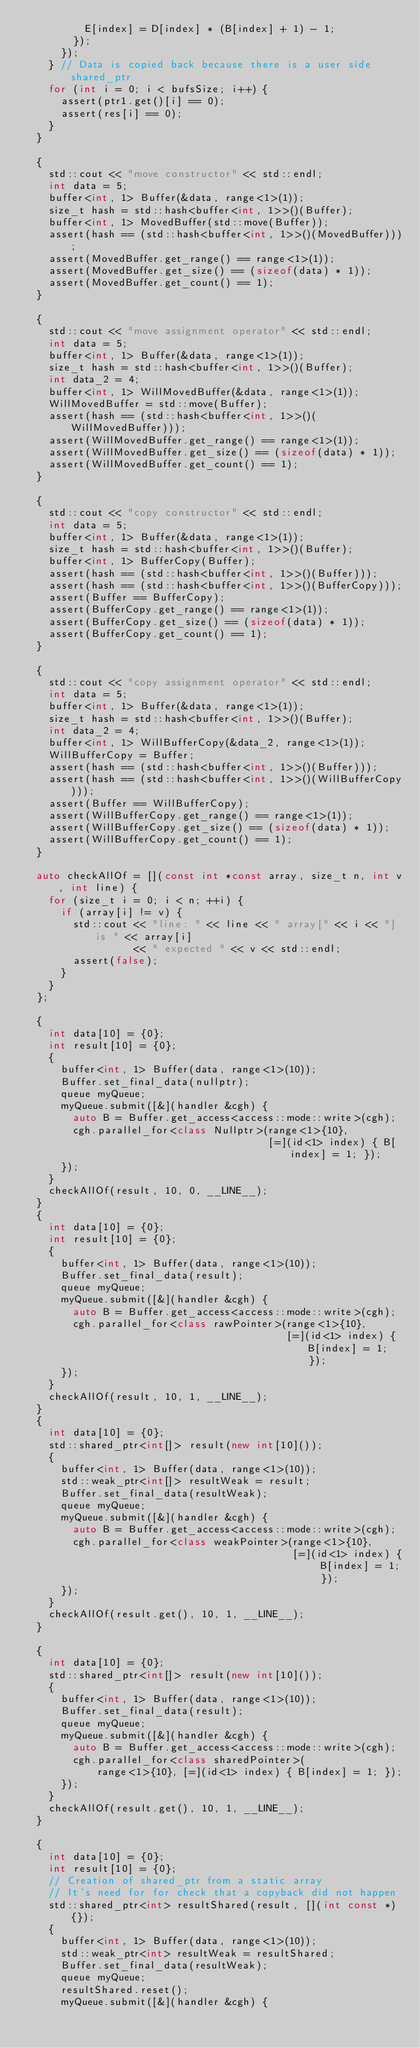<code> <loc_0><loc_0><loc_500><loc_500><_C++_>          E[index] = D[index] * (B[index] + 1) - 1;
        });
      });
    } // Data is copied back because there is a user side shared_ptr
    for (int i = 0; i < bufsSize; i++) {
      assert(ptr1.get()[i] == 0);
      assert(res[i] == 0);
    }
  }

  {
    std::cout << "move constructor" << std::endl;
    int data = 5;
    buffer<int, 1> Buffer(&data, range<1>(1));
    size_t hash = std::hash<buffer<int, 1>>()(Buffer);
    buffer<int, 1> MovedBuffer(std::move(Buffer));
    assert(hash == (std::hash<buffer<int, 1>>()(MovedBuffer)));
    assert(MovedBuffer.get_range() == range<1>(1));
    assert(MovedBuffer.get_size() == (sizeof(data) * 1));
    assert(MovedBuffer.get_count() == 1);
  }

  {
    std::cout << "move assignment operator" << std::endl;
    int data = 5;
    buffer<int, 1> Buffer(&data, range<1>(1));
    size_t hash = std::hash<buffer<int, 1>>()(Buffer);
    int data_2 = 4;
    buffer<int, 1> WillMovedBuffer(&data, range<1>(1));
    WillMovedBuffer = std::move(Buffer);
    assert(hash == (std::hash<buffer<int, 1>>()(WillMovedBuffer)));
    assert(WillMovedBuffer.get_range() == range<1>(1));
    assert(WillMovedBuffer.get_size() == (sizeof(data) * 1));
    assert(WillMovedBuffer.get_count() == 1);
  }

  {
    std::cout << "copy constructor" << std::endl;
    int data = 5;
    buffer<int, 1> Buffer(&data, range<1>(1));
    size_t hash = std::hash<buffer<int, 1>>()(Buffer);
    buffer<int, 1> BufferCopy(Buffer);
    assert(hash == (std::hash<buffer<int, 1>>()(Buffer)));
    assert(hash == (std::hash<buffer<int, 1>>()(BufferCopy)));
    assert(Buffer == BufferCopy);
    assert(BufferCopy.get_range() == range<1>(1));
    assert(BufferCopy.get_size() == (sizeof(data) * 1));
    assert(BufferCopy.get_count() == 1);
  }

  {
    std::cout << "copy assignment operator" << std::endl;
    int data = 5;
    buffer<int, 1> Buffer(&data, range<1>(1));
    size_t hash = std::hash<buffer<int, 1>>()(Buffer);
    int data_2 = 4;
    buffer<int, 1> WillBufferCopy(&data_2, range<1>(1));
    WillBufferCopy = Buffer;
    assert(hash == (std::hash<buffer<int, 1>>()(Buffer)));
    assert(hash == (std::hash<buffer<int, 1>>()(WillBufferCopy)));
    assert(Buffer == WillBufferCopy);
    assert(WillBufferCopy.get_range() == range<1>(1));
    assert(WillBufferCopy.get_size() == (sizeof(data) * 1));
    assert(WillBufferCopy.get_count() == 1);
  }

  auto checkAllOf = [](const int *const array, size_t n, int v, int line) {
    for (size_t i = 0; i < n; ++i) {
      if (array[i] != v) {
        std::cout << "line: " << line << " array[" << i << "] is " << array[i]
                  << " expected " << v << std::endl;
        assert(false);
      }
    }
  };

  {
    int data[10] = {0};
    int result[10] = {0};
    {
      buffer<int, 1> Buffer(data, range<1>(10));
      Buffer.set_final_data(nullptr);
      queue myQueue;
      myQueue.submit([&](handler &cgh) {
        auto B = Buffer.get_access<access::mode::write>(cgh);
        cgh.parallel_for<class Nullptr>(range<1>{10},
                                        [=](id<1> index) { B[index] = 1; });
      });
    }
    checkAllOf(result, 10, 0, __LINE__);
  }
  {
    int data[10] = {0};
    int result[10] = {0};
    {
      buffer<int, 1> Buffer(data, range<1>(10));
      Buffer.set_final_data(result);
      queue myQueue;
      myQueue.submit([&](handler &cgh) {
        auto B = Buffer.get_access<access::mode::write>(cgh);
        cgh.parallel_for<class rawPointer>(range<1>{10},
                                           [=](id<1> index) { B[index] = 1; });
      });
    }
    checkAllOf(result, 10, 1, __LINE__);
  }
  {
    int data[10] = {0};
    std::shared_ptr<int[]> result(new int[10]());
    {
      buffer<int, 1> Buffer(data, range<1>(10));
      std::weak_ptr<int[]> resultWeak = result;
      Buffer.set_final_data(resultWeak);
      queue myQueue;
      myQueue.submit([&](handler &cgh) {
        auto B = Buffer.get_access<access::mode::write>(cgh);
        cgh.parallel_for<class weakPointer>(range<1>{10},
                                            [=](id<1> index) { B[index] = 1; });
      });
    }
    checkAllOf(result.get(), 10, 1, __LINE__);
  }

  {
    int data[10] = {0};
    std::shared_ptr<int[]> result(new int[10]());
    {
      buffer<int, 1> Buffer(data, range<1>(10));
      Buffer.set_final_data(result);
      queue myQueue;
      myQueue.submit([&](handler &cgh) {
        auto B = Buffer.get_access<access::mode::write>(cgh);
        cgh.parallel_for<class sharedPointer>(
            range<1>{10}, [=](id<1> index) { B[index] = 1; });
      });
    }
    checkAllOf(result.get(), 10, 1, __LINE__);
  }

  {
    int data[10] = {0};
    int result[10] = {0};
    // Creation of shared_ptr from a static array
    // It's need for for check that a copyback did not happen
    std::shared_ptr<int> resultShared(result, [](int const *) {});
    {
      buffer<int, 1> Buffer(data, range<1>(10));
      std::weak_ptr<int> resultWeak = resultShared;
      Buffer.set_final_data(resultWeak);
      queue myQueue;
      resultShared.reset();
      myQueue.submit([&](handler &cgh) {</code> 